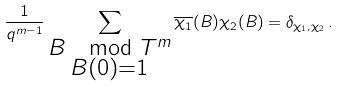<formula> <loc_0><loc_0><loc_500><loc_500>\frac { 1 } { q ^ { m - 1 } } \sum _ { \substack { B \mod T ^ { m } \\ B ( 0 ) = 1 } } \overline { \chi _ { 1 } } ( B ) \chi _ { 2 } ( B ) = \delta _ { \chi _ { 1 } , \chi _ { 2 } } \, .</formula> 